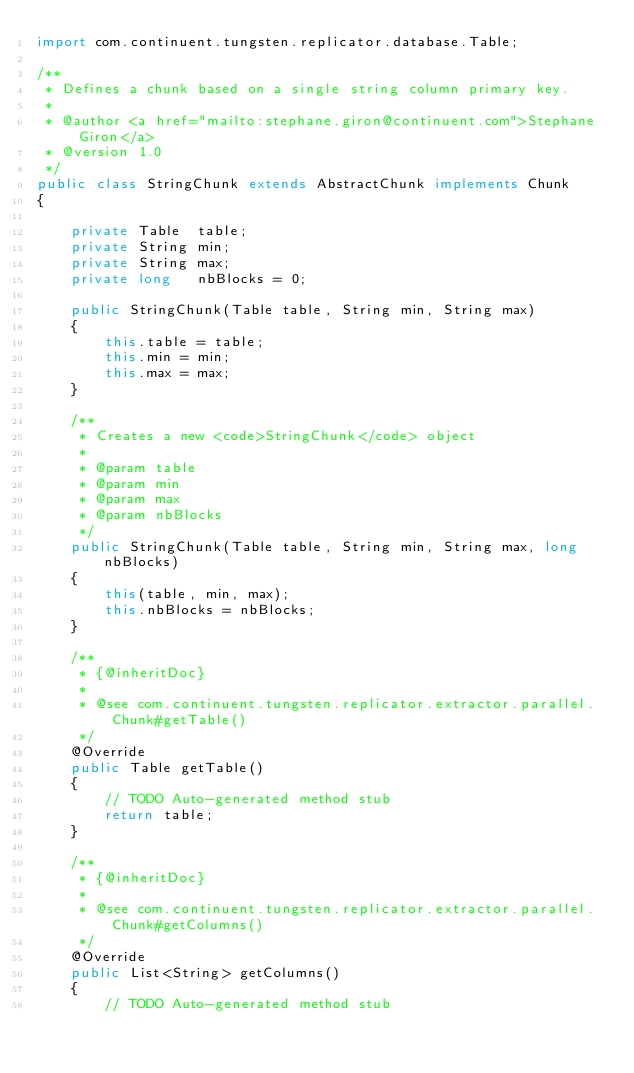Convert code to text. <code><loc_0><loc_0><loc_500><loc_500><_Java_>import com.continuent.tungsten.replicator.database.Table;

/**
 * Defines a chunk based on a single string column primary key.
 * 
 * @author <a href="mailto:stephane.giron@continuent.com">Stephane Giron</a>
 * @version 1.0
 */
public class StringChunk extends AbstractChunk implements Chunk
{

    private Table  table;
    private String min;
    private String max;
    private long   nbBlocks = 0;

    public StringChunk(Table table, String min, String max)
    {
        this.table = table;
        this.min = min;
        this.max = max;
    }

    /**
     * Creates a new <code>StringChunk</code> object
     * 
     * @param table
     * @param min
     * @param max
     * @param nbBlocks
     */
    public StringChunk(Table table, String min, String max, long nbBlocks)
    {
        this(table, min, max);
        this.nbBlocks = nbBlocks;
    }

    /**
     * {@inheritDoc}
     * 
     * @see com.continuent.tungsten.replicator.extractor.parallel.Chunk#getTable()
     */
    @Override
    public Table getTable()
    {
        // TODO Auto-generated method stub
        return table;
    }

    /**
     * {@inheritDoc}
     * 
     * @see com.continuent.tungsten.replicator.extractor.parallel.Chunk#getColumns()
     */
    @Override
    public List<String> getColumns()
    {
        // TODO Auto-generated method stub</code> 